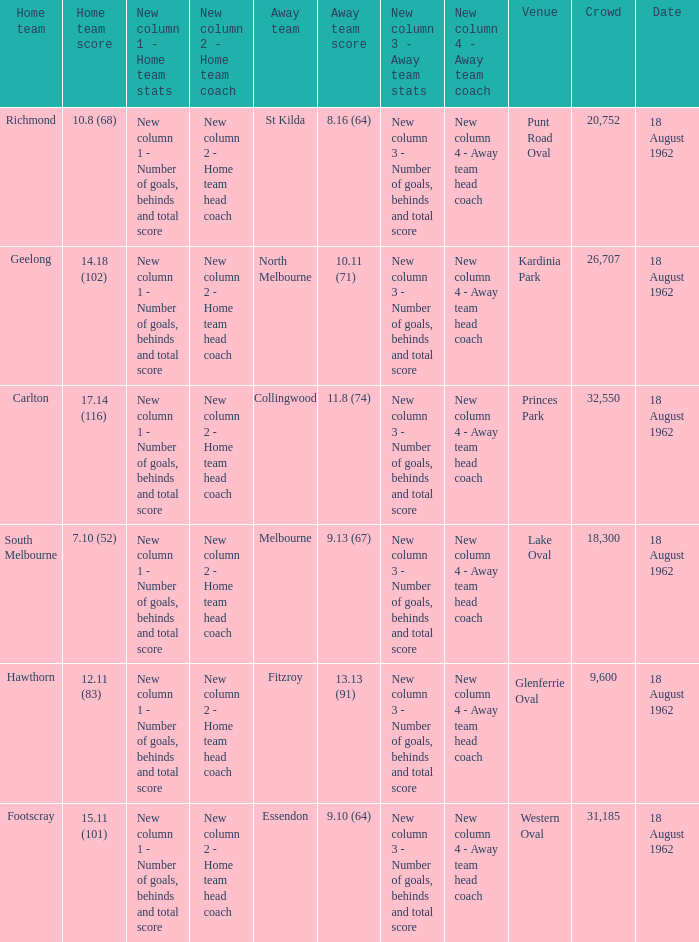11 (83) was the number of attendees higher than 31,185? None. 